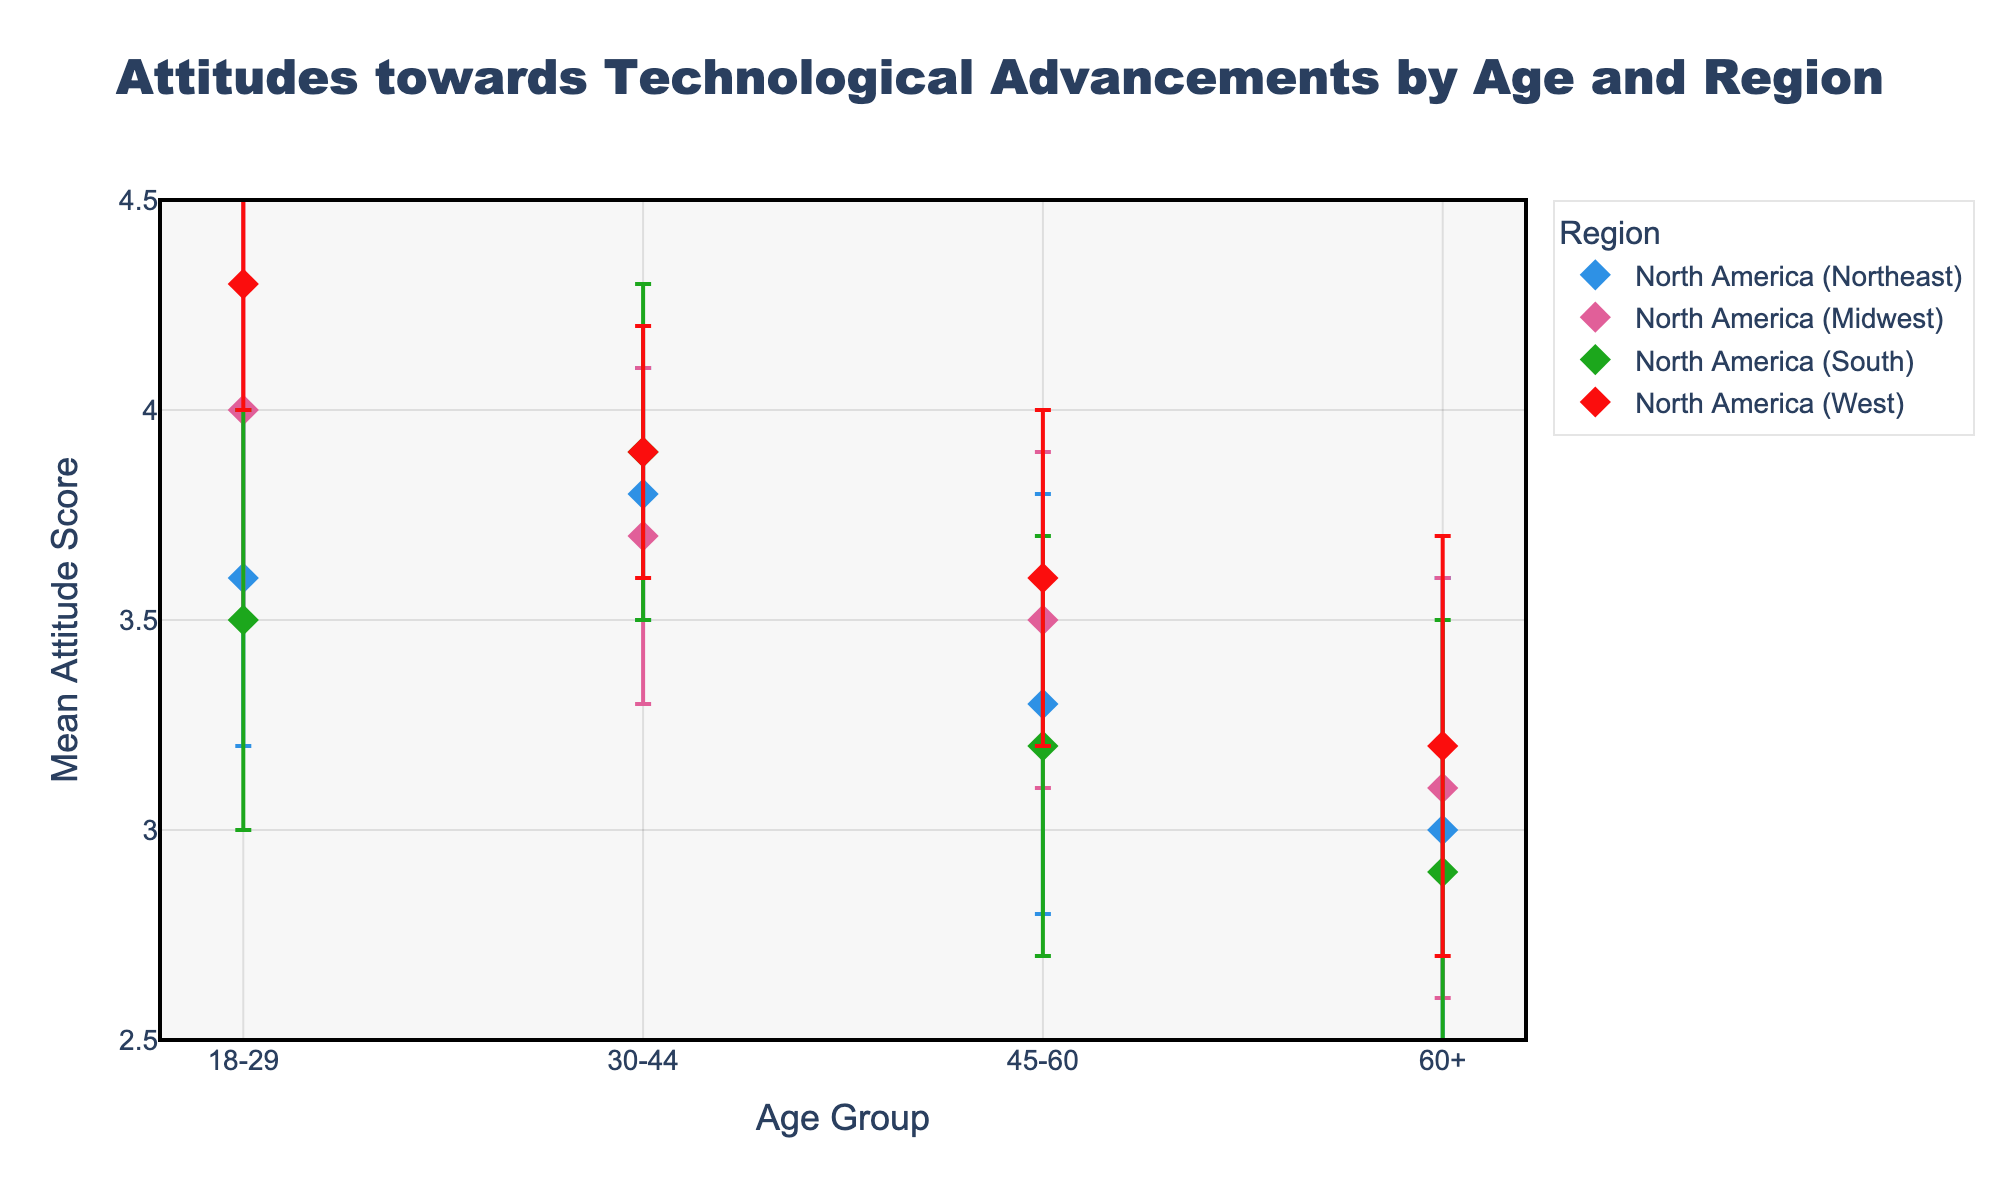Which age group in the Northeast region has the highest mean attitude score? Look at the data points for the Northeast region and compare the mean scores for each age group (18-29: 3.6, 30-44: 3.8, 45-60: 3.3, 60+: 3.0). The highest mean score is for the 30-44 age group.
Answer: 30-44 How does the mean attitude score for the 18-29 age group in the Midwest compare to that in the Northeast? Compare the mean scores of the 18-29 age group between the Midwest (4.0) and the Northeast (3.6). The Midwest has a higher mean score.
Answer: Higher in the Midwest Which region shows the greatest variation in mean attitude scores across age groups? Look at the error margins in each region to assess variation. The Northeast has error margins ranging from 0.3 to 0.6, the Midwest from 0.4 to 0.5, the South from 0.4 to 0.6, and the West from 0.3 to 0.5. The variations can be judged by the range of mean scores as well, with the Northeast (3.0 to 3.8) showing the greatest range.
Answer: Northeast What is the mean attitude score difference between the youngest (18-29) and the oldest (60+) age groups in the South region? Subtract the mean score of the 60+ age group (2.9) from the mean score of the 18-29 age group (3.5). \(3.5 - 2.9 = 0.6\).
Answer: 0.6 Which error margin is the largest in the dataset? Examine all error margins across regions and age groups. The largest error margin is 0.6, found in the Northeast (60+) and South (60+).
Answer: 0.6 Does any age group in the West region have a mean attitude score above 4? Look at the scores for the West region. Only the 18-29 age group has a score above 4, which is 4.3.
Answer: 18-29 Compare the mean attitude score of the 45-60 age group in the West with that in the Midwest. Which is higher? Compare the mean scores for the 45-60 age group in the West (3.6) and the Midwest (3.5). The mean score is slightly higher in the West.
Answer: West What is the average mean attitude score for the 60+ age group across all regions? Calculate the average of the mean scores for the 60+ age group: \((3.0 + 3.1 + 2.9 + 3.2) / 4 = 3.05\).
Answer: 3.05 